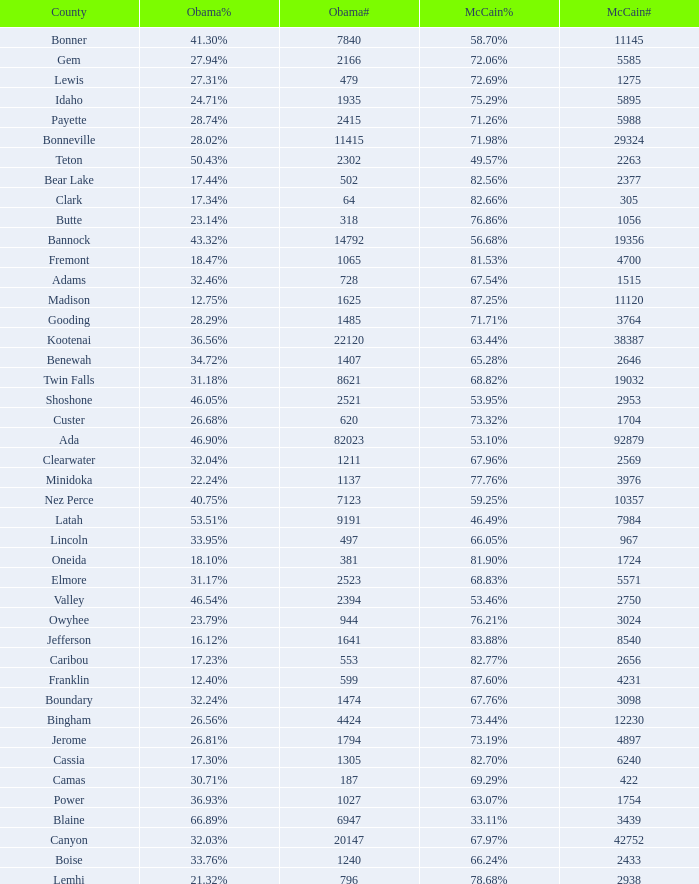What is the maximum McCain population turnout number? 92879.0. 